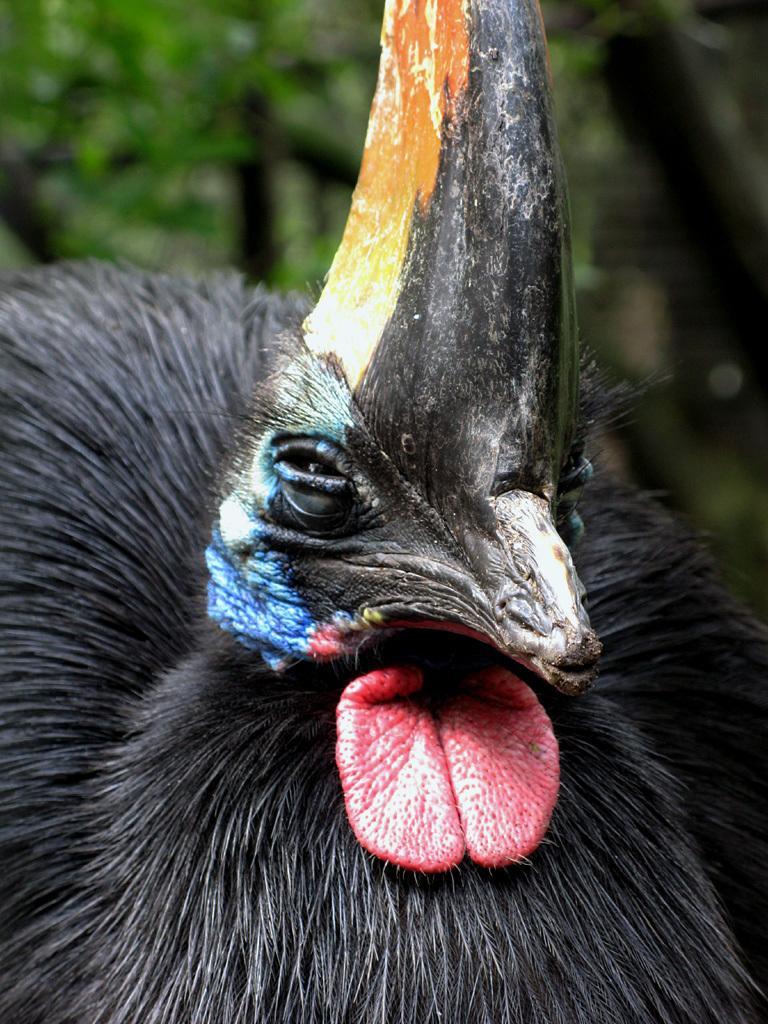In one or two sentences, can you explain what this image depicts? In this image we can see a bird. In the background there are trees. 